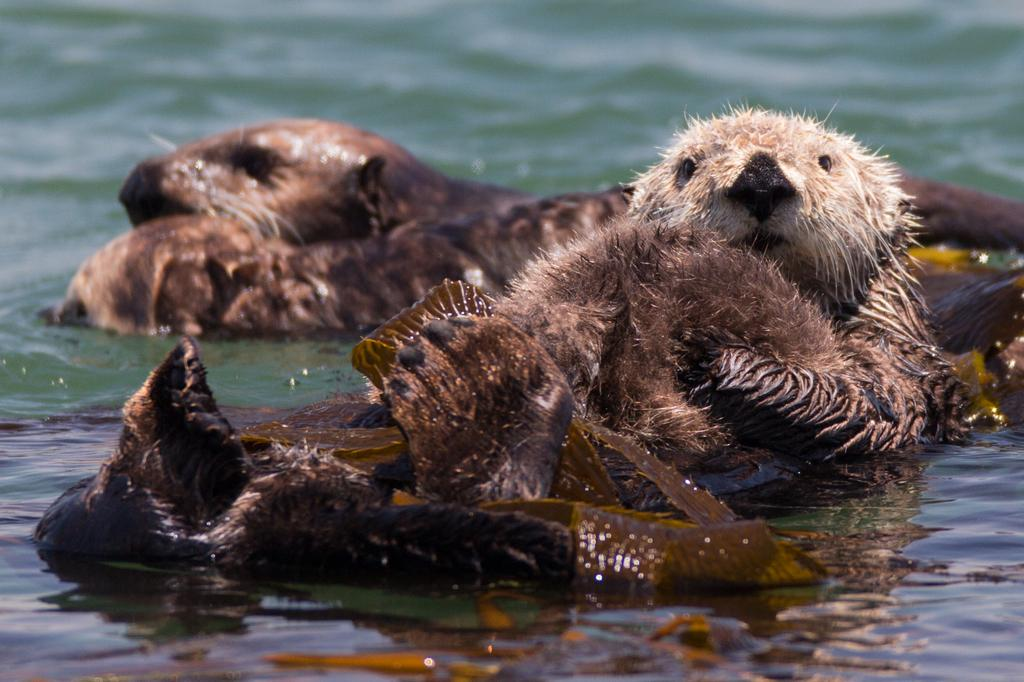What animals are in the middle of the image? There are skinned otters in the middle of the image. What is visible in the background of the image? Water is visible in the image. What is happening to the water in the image? Waves are present in the water. What type of teaching method is being demonstrated in the image? There is no teaching method or any indication of teaching in the image. 